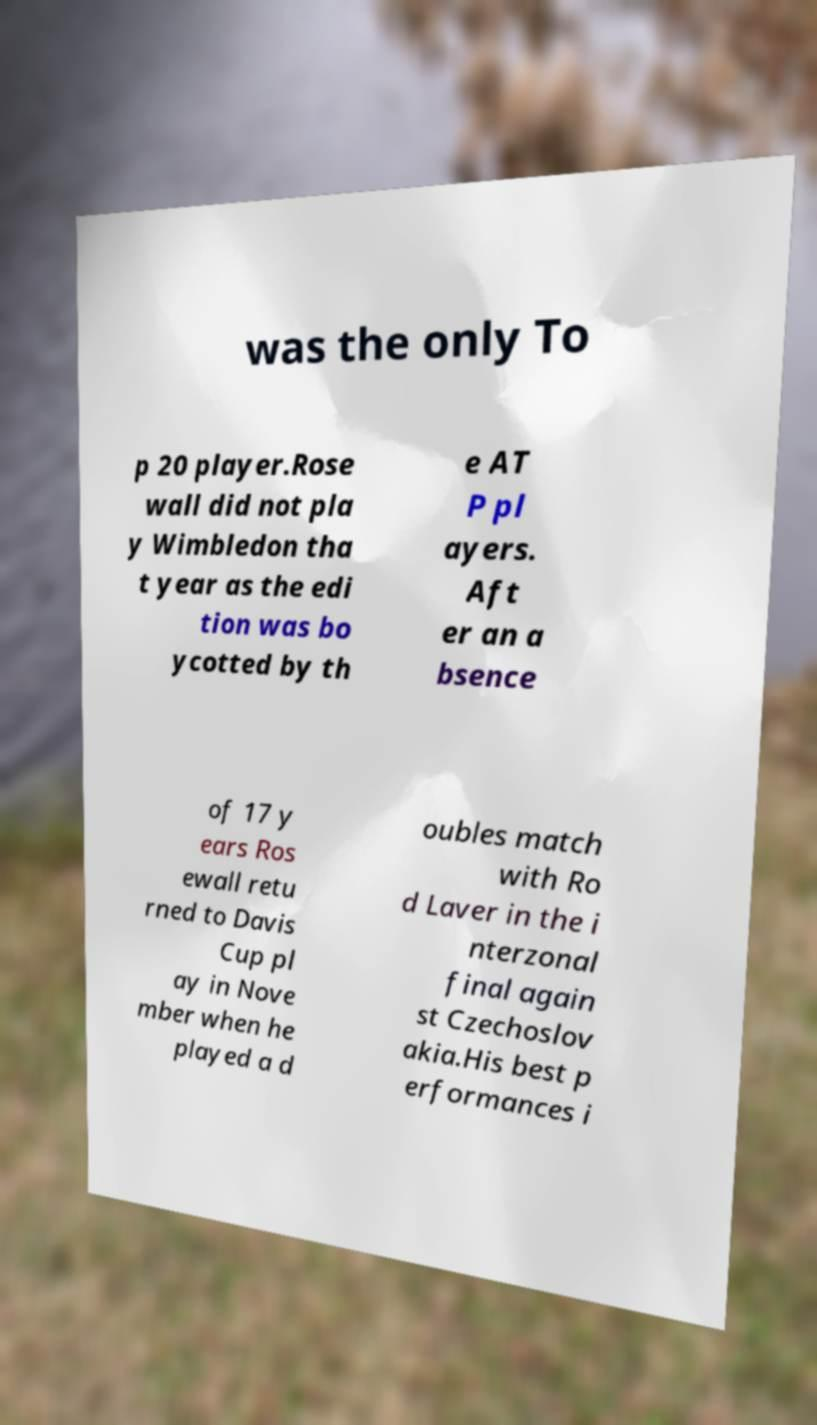Can you read and provide the text displayed in the image?This photo seems to have some interesting text. Can you extract and type it out for me? was the only To p 20 player.Rose wall did not pla y Wimbledon tha t year as the edi tion was bo ycotted by th e AT P pl ayers. Aft er an a bsence of 17 y ears Ros ewall retu rned to Davis Cup pl ay in Nove mber when he played a d oubles match with Ro d Laver in the i nterzonal final again st Czechoslov akia.His best p erformances i 